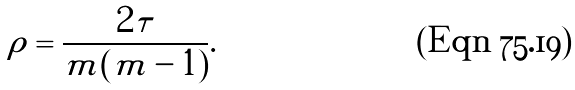<formula> <loc_0><loc_0><loc_500><loc_500>\rho = \frac { 2 \tau } { m ( m - 1 ) } .</formula> 